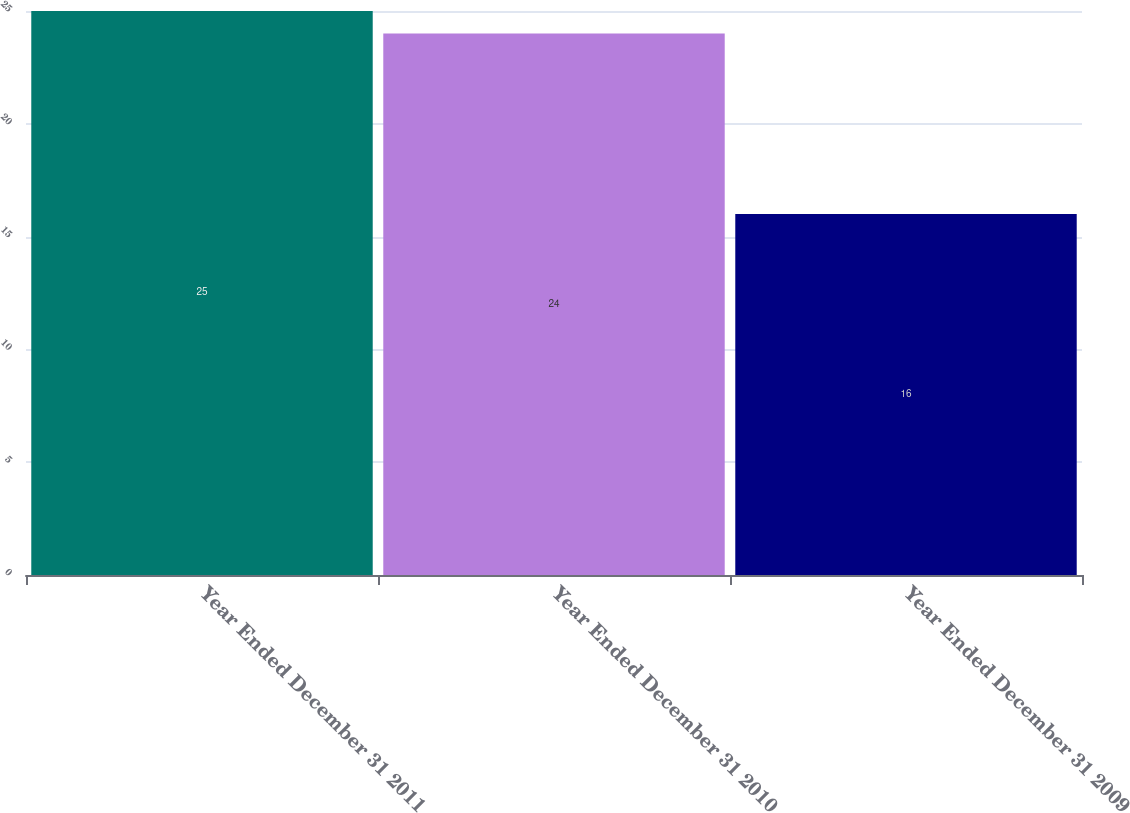Convert chart. <chart><loc_0><loc_0><loc_500><loc_500><bar_chart><fcel>Year Ended December 31 2011<fcel>Year Ended December 31 2010<fcel>Year Ended December 31 2009<nl><fcel>25<fcel>24<fcel>16<nl></chart> 